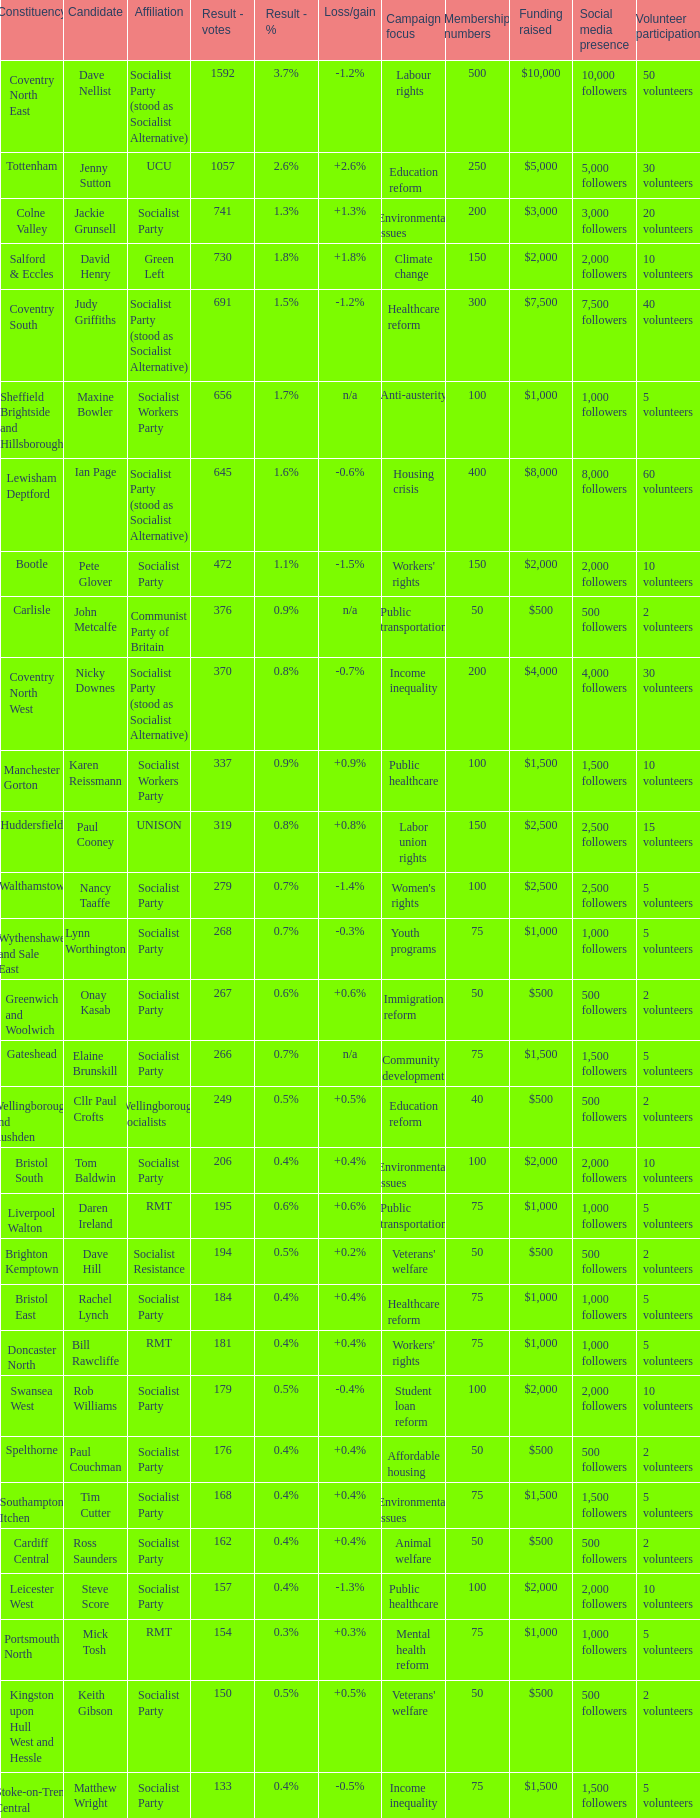What is the highest vote count in the huddersfield constituency? 319.0. 